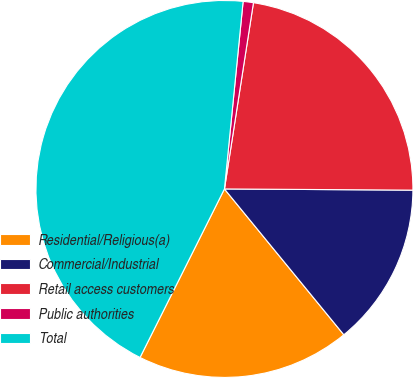Convert chart. <chart><loc_0><loc_0><loc_500><loc_500><pie_chart><fcel>Residential/Religious(a)<fcel>Commercial/Industrial<fcel>Retail access customers<fcel>Public authorities<fcel>Total<nl><fcel>18.31%<fcel>13.98%<fcel>22.64%<fcel>0.88%<fcel>44.19%<nl></chart> 